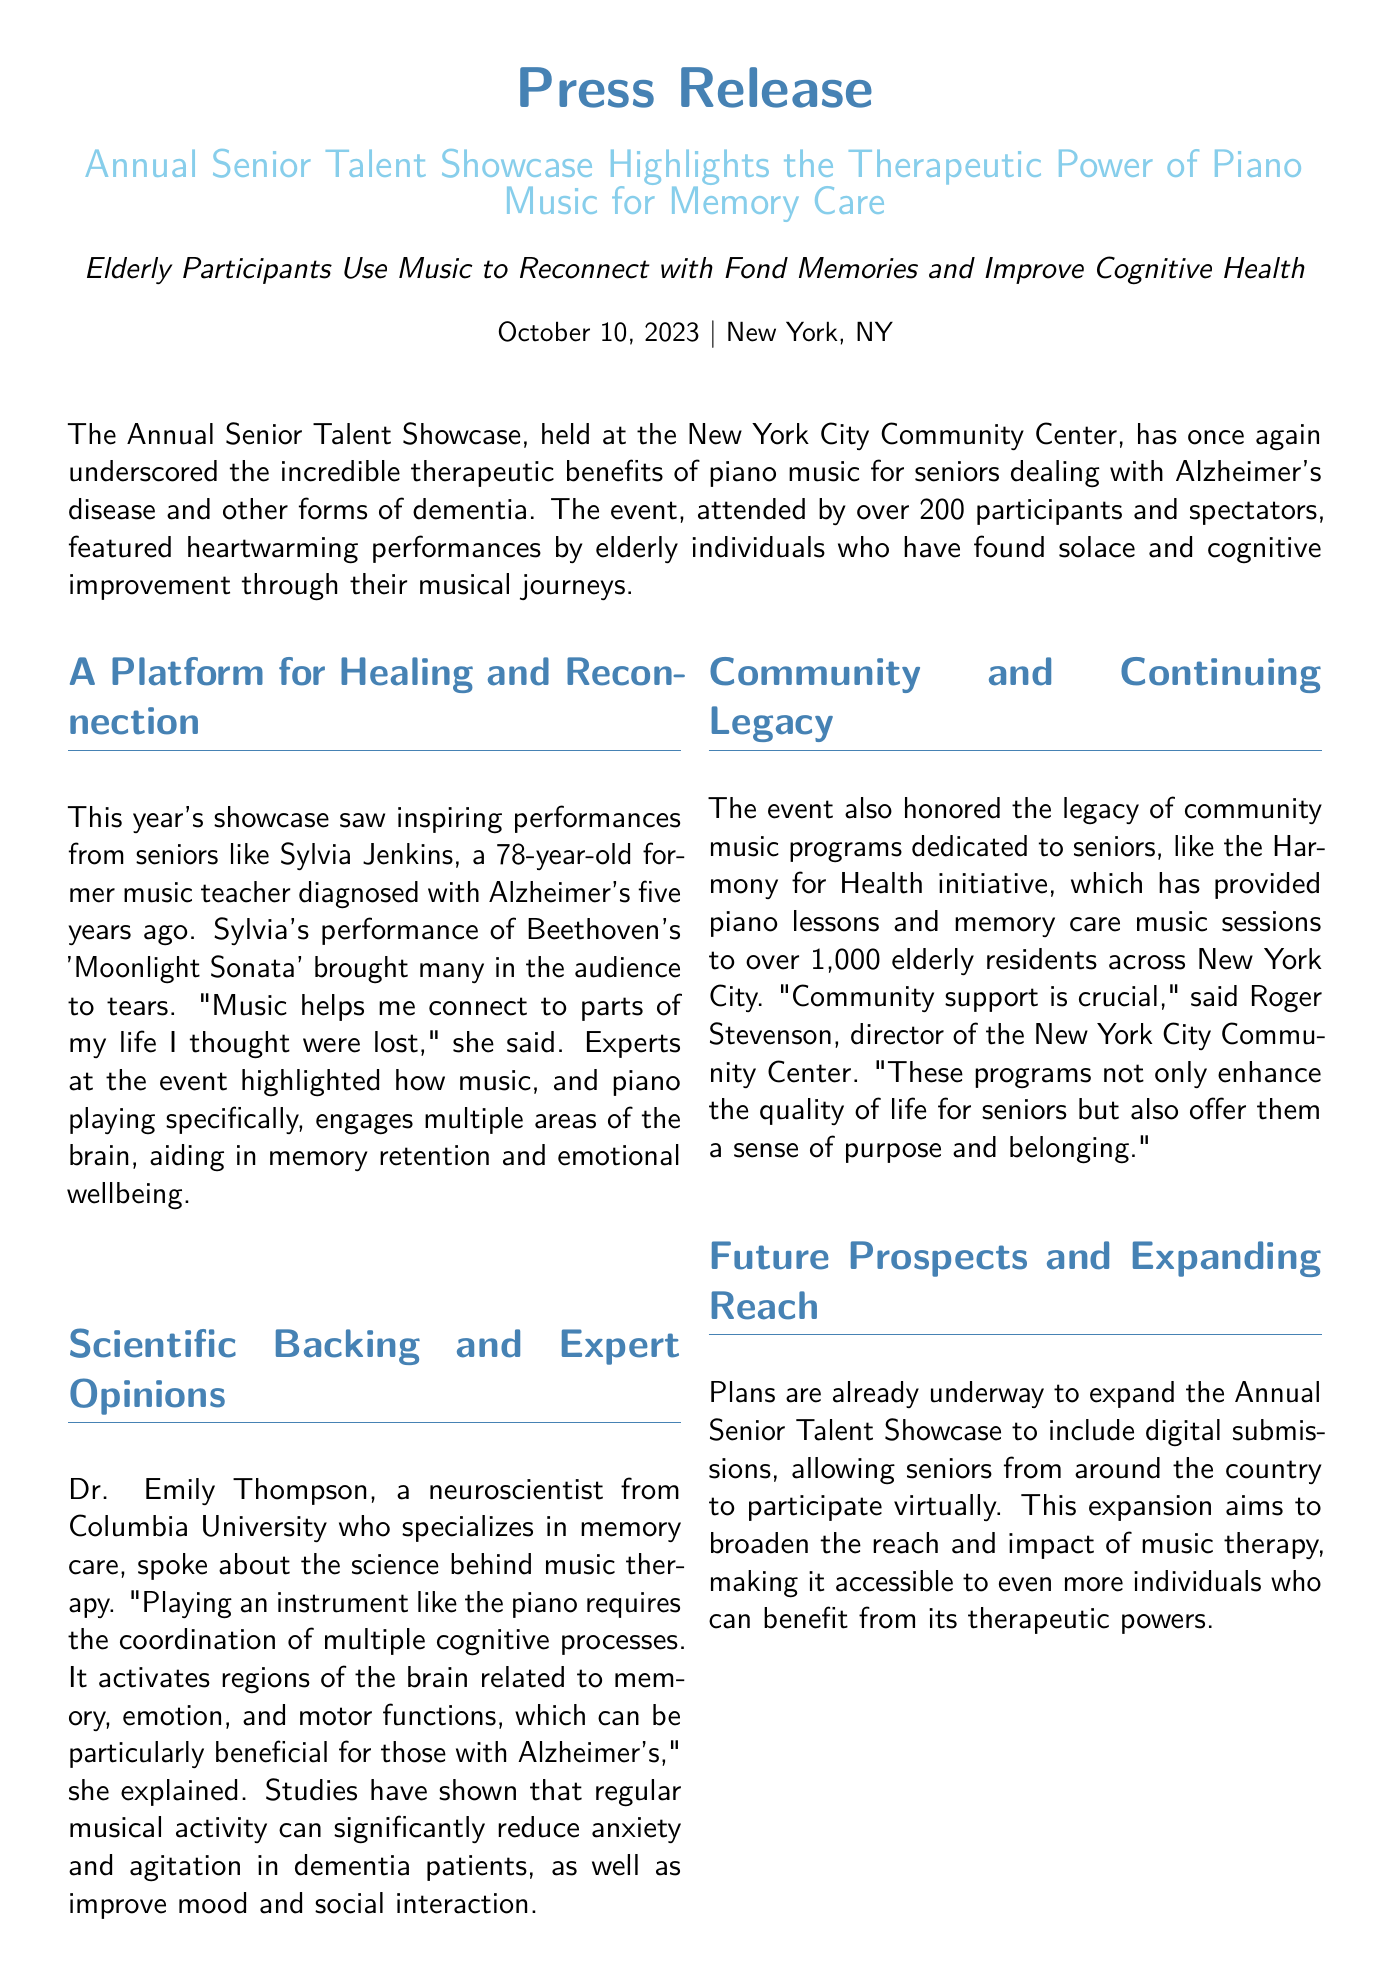What is the date of the press release? The date of the press release is mentioned in the first section.
Answer: October 10, 2023 How many participants and spectators attended the event? The number of attendees is stated in the first paragraph of the document.
Answer: Over 200 Who is Sylvia Jenkins? Sylvia Jenkins is introduced in the second section highlighting her performance.
Answer: A 78-year-old former music teacher What piece did Sylvia Jenkins perform? The specific piece performed by Sylvia is mentioned in the showcase details.
Answer: Beethoven's 'Moonlight Sonata' What did Dr. Emily Thompson specialize in? Dr. Emily Thompson's area of expertise is identified in the scientific backing section.
Answer: Memory care What organization initiated the Harmony for Health program? The program dedicated to seniors is referenced in the community section of the document.
Answer: New York City Community Center What therapeutic benefit of piano playing was emphasized? The therapeutic benefit related to piano playing is discussed by experts in the document.
Answer: Memory retention and emotional wellbeing What future plans are mentioned for the showcase? The plans for the showcase's future expansion are explained towards the end.
Answer: Include digital submissions Who is Roger Stevenson? Roger Stevenson is mentioned as the director in the community section.
Answer: Director of the New York City Community Center 